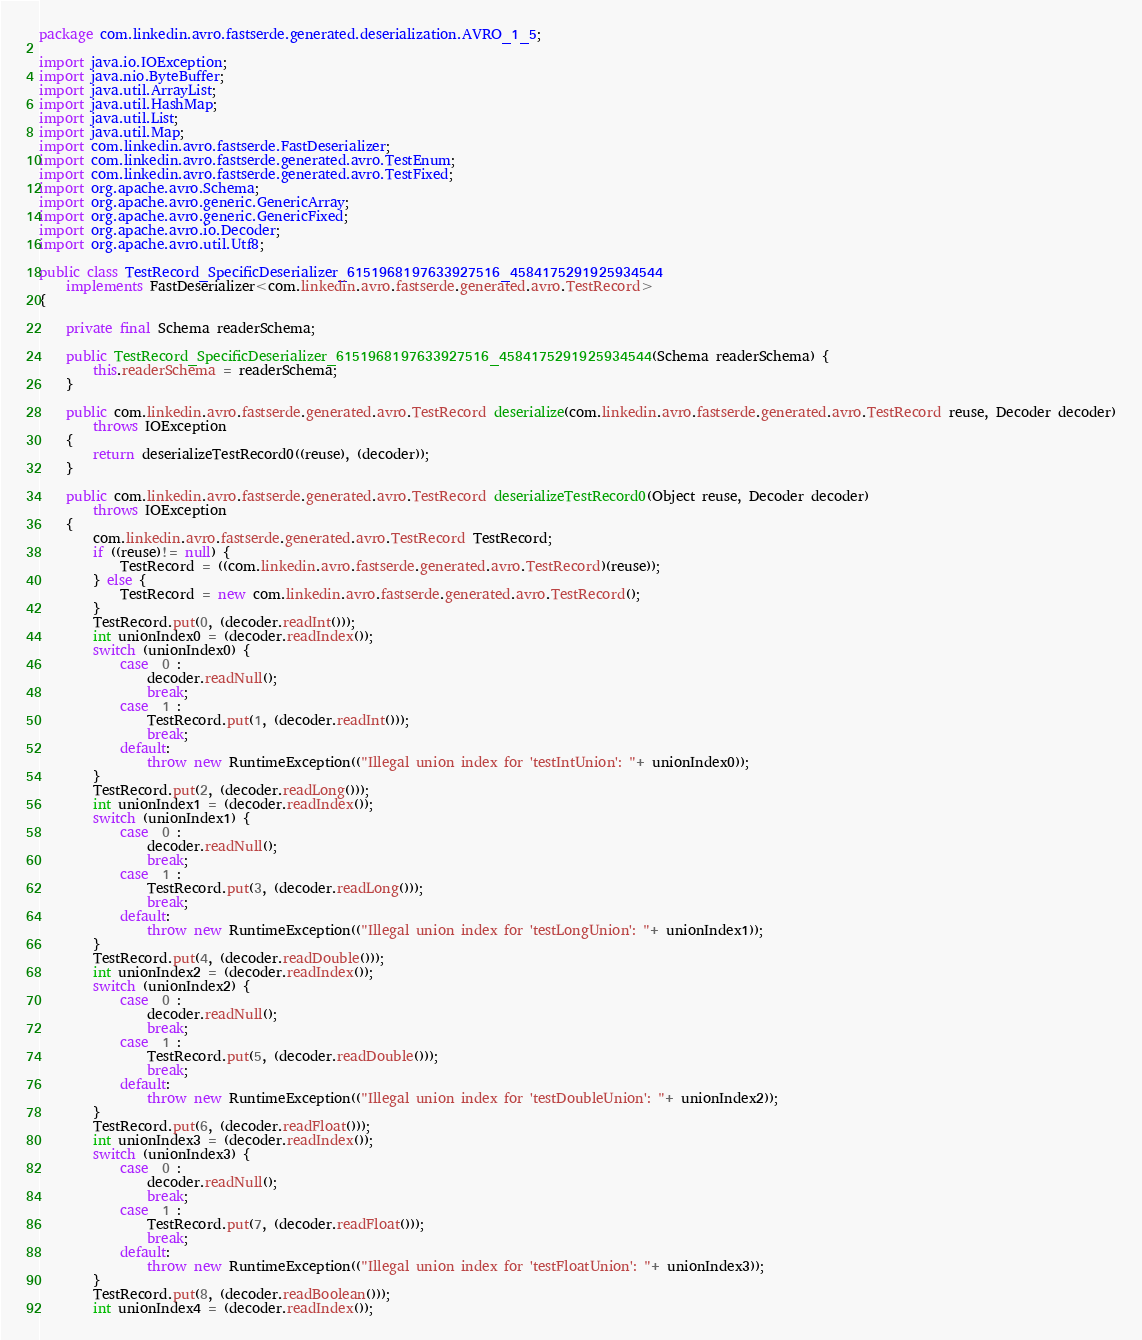Convert code to text. <code><loc_0><loc_0><loc_500><loc_500><_Java_>
package com.linkedin.avro.fastserde.generated.deserialization.AVRO_1_5;

import java.io.IOException;
import java.nio.ByteBuffer;
import java.util.ArrayList;
import java.util.HashMap;
import java.util.List;
import java.util.Map;
import com.linkedin.avro.fastserde.FastDeserializer;
import com.linkedin.avro.fastserde.generated.avro.TestEnum;
import com.linkedin.avro.fastserde.generated.avro.TestFixed;
import org.apache.avro.Schema;
import org.apache.avro.generic.GenericArray;
import org.apache.avro.generic.GenericFixed;
import org.apache.avro.io.Decoder;
import org.apache.avro.util.Utf8;

public class TestRecord_SpecificDeserializer_6151968197633927516_4584175291925934544
    implements FastDeserializer<com.linkedin.avro.fastserde.generated.avro.TestRecord>
{

    private final Schema readerSchema;

    public TestRecord_SpecificDeserializer_6151968197633927516_4584175291925934544(Schema readerSchema) {
        this.readerSchema = readerSchema;
    }

    public com.linkedin.avro.fastserde.generated.avro.TestRecord deserialize(com.linkedin.avro.fastserde.generated.avro.TestRecord reuse, Decoder decoder)
        throws IOException
    {
        return deserializeTestRecord0((reuse), (decoder));
    }

    public com.linkedin.avro.fastserde.generated.avro.TestRecord deserializeTestRecord0(Object reuse, Decoder decoder)
        throws IOException
    {
        com.linkedin.avro.fastserde.generated.avro.TestRecord TestRecord;
        if ((reuse)!= null) {
            TestRecord = ((com.linkedin.avro.fastserde.generated.avro.TestRecord)(reuse));
        } else {
            TestRecord = new com.linkedin.avro.fastserde.generated.avro.TestRecord();
        }
        TestRecord.put(0, (decoder.readInt()));
        int unionIndex0 = (decoder.readIndex());
        switch (unionIndex0) {
            case  0 :
                decoder.readNull();
                break;
            case  1 :
                TestRecord.put(1, (decoder.readInt()));
                break;
            default:
                throw new RuntimeException(("Illegal union index for 'testIntUnion': "+ unionIndex0));
        }
        TestRecord.put(2, (decoder.readLong()));
        int unionIndex1 = (decoder.readIndex());
        switch (unionIndex1) {
            case  0 :
                decoder.readNull();
                break;
            case  1 :
                TestRecord.put(3, (decoder.readLong()));
                break;
            default:
                throw new RuntimeException(("Illegal union index for 'testLongUnion': "+ unionIndex1));
        }
        TestRecord.put(4, (decoder.readDouble()));
        int unionIndex2 = (decoder.readIndex());
        switch (unionIndex2) {
            case  0 :
                decoder.readNull();
                break;
            case  1 :
                TestRecord.put(5, (decoder.readDouble()));
                break;
            default:
                throw new RuntimeException(("Illegal union index for 'testDoubleUnion': "+ unionIndex2));
        }
        TestRecord.put(6, (decoder.readFloat()));
        int unionIndex3 = (decoder.readIndex());
        switch (unionIndex3) {
            case  0 :
                decoder.readNull();
                break;
            case  1 :
                TestRecord.put(7, (decoder.readFloat()));
                break;
            default:
                throw new RuntimeException(("Illegal union index for 'testFloatUnion': "+ unionIndex3));
        }
        TestRecord.put(8, (decoder.readBoolean()));
        int unionIndex4 = (decoder.readIndex());</code> 